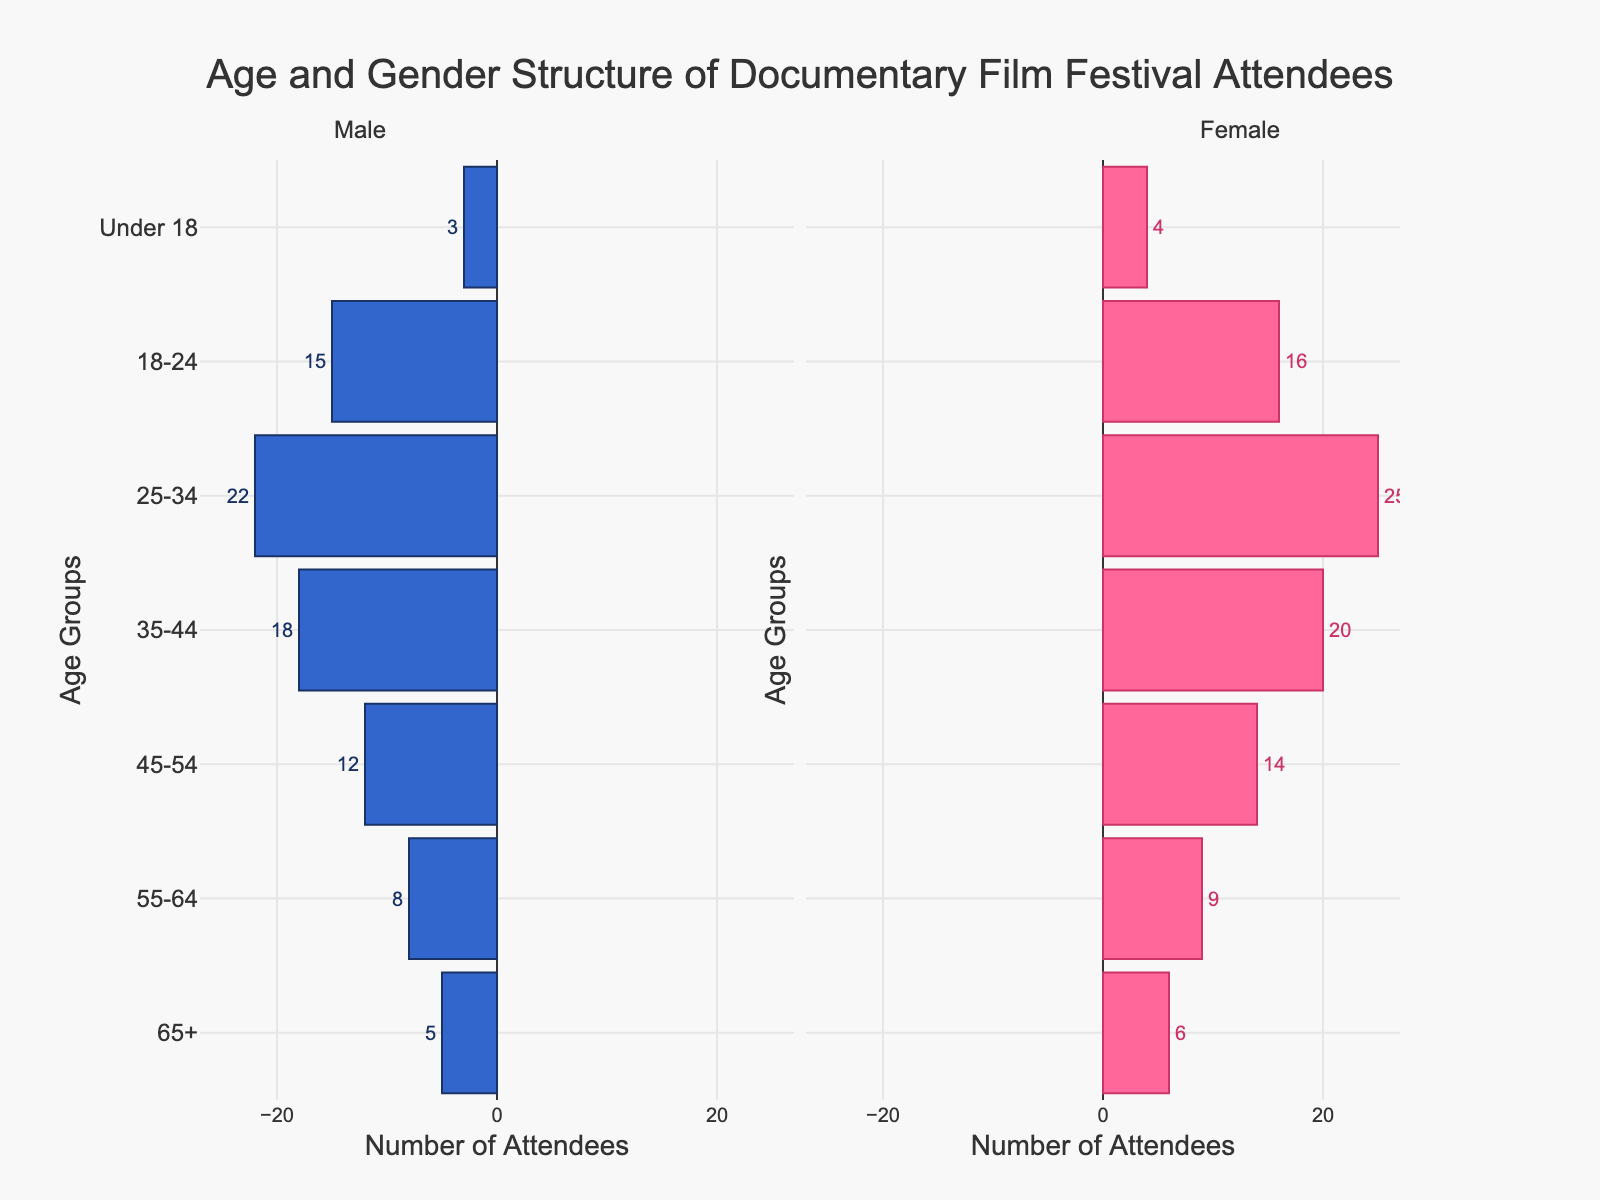What is the title of the figure? The title is usually displayed at the top of the figure. For this plot, the title is "Age and Gender Structure of Documentary Film Festival Attendees".
Answer: Age and Gender Structure of Documentary Film Festival Attendees How many age groups are represented in the plot? The plot has bars representing different age groups. By counting these, we find that there are 7 age groups.
Answer: 7 Which age group has the highest number of female attendees? By looking at the female bars, the age group with the longest bar for females is "25-34" with a length representing 25 attendees.
Answer: 25-34 What is the total number of attendees in the "45-54" age group? To find the total, we add the male and female attendees in this age group: 12 (male) + 14 (female) = 26.
Answer: 26 How does the number of attendees aged "18-24" compare between males and females? Comparing the bars for the "18-24" age group, males have 15 attendees while females have 16. So, females have 1 more attendee than males in this age group.
Answer: Females have 1 more attendee What is the difference in the number of attendees between the "Under 18" and "55-64" age groups? For "Under 18", the total number is 3 (male) + 4 (female) = 7. For the "55-64" group, the total is 8 (male) + 9 (female) = 17. The difference is 17 - 7 = 10.
Answer: 10 Which gender has a larger population in the "35-44" age group? By comparing the bar lengths, males (18) and females (20), it's clear that females are more than males by 2 attendees.
Answer: Female What is the ratio of male to female attendees in the "65+" age group? For this age group, there are 5 males and 6 females. The ratio is 5:6.
Answer: 5:6 What is the smallest age group's total number of attendees, and which is it? By looking at the sum of males and females for each group, "Under 18" has the smallest with 3 (male) + 4 (female) = 7.
Answer: Under 18 with 7 attendees What is the average number of female attendees across all age groups? To find the average, sum the female values (6+9+14+20+25+16+4) and divide by the number of groups (7). Sum = 94, average = 94 / 7 = 13.43.
Answer: 13.43 